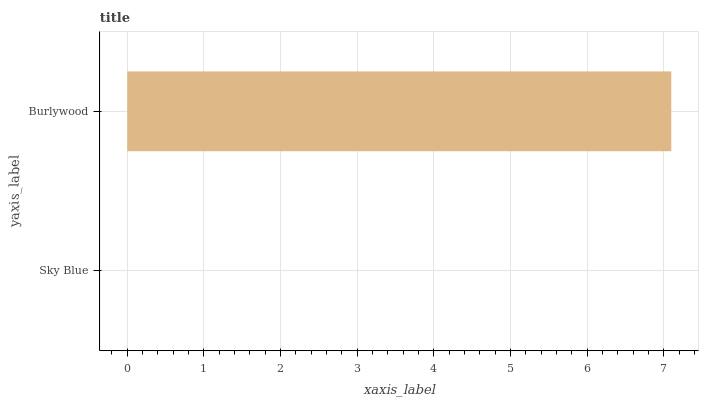Is Sky Blue the minimum?
Answer yes or no. Yes. Is Burlywood the maximum?
Answer yes or no. Yes. Is Burlywood the minimum?
Answer yes or no. No. Is Burlywood greater than Sky Blue?
Answer yes or no. Yes. Is Sky Blue less than Burlywood?
Answer yes or no. Yes. Is Sky Blue greater than Burlywood?
Answer yes or no. No. Is Burlywood less than Sky Blue?
Answer yes or no. No. Is Burlywood the high median?
Answer yes or no. Yes. Is Sky Blue the low median?
Answer yes or no. Yes. Is Sky Blue the high median?
Answer yes or no. No. Is Burlywood the low median?
Answer yes or no. No. 